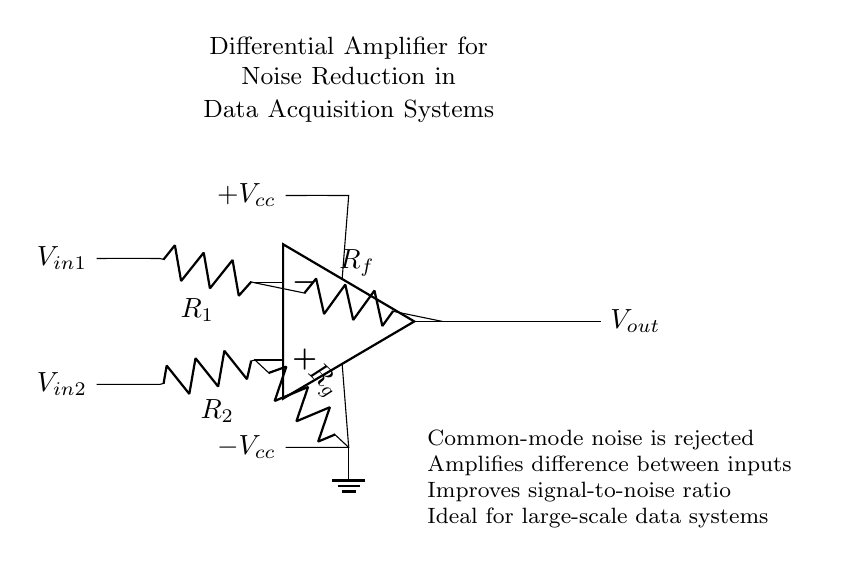What type of amplifier is shown? The circuit is labeled as a "Differential Amplifier" at the top, indicating its classification.
Answer: Differential Amplifier What are the input voltages? The inputs are labeled as V in one and V in two, which show where the input signals are applied in the circuit.
Answer: V in one, V in two What do R1 and R2 represent? R1 is connected to the inverting input while R2 connects to the non-inverting input, indicating they are the input resistors.
Answer: Input resistors What is the purpose of Rf? Rf is labeled as the feedback resistor connected from the output back to the inverting input, which is typical in amplifier circuits to control gain.
Answer: Feedback resistor How does this amplifier reduce noise? The noise reduction is explained in detail on the right side of the circuit; it states that common-mode noise is rejected, and it amplifies the difference between inputs to improve the signal-to-noise ratio.
Answer: Rejects common-mode noise What is the role of the power supply voltages? The circuit has both +Vcc and -Vcc connected to the op-amp, providing the necessary supply voltages for operation, allowing the amplifier to work properly over a range of output signals.
Answer: Supply voltages for operation What is the output of the amplifier? The output is labeled as V out, which signifies the processed signal after amplification of the input difference.
Answer: V out 